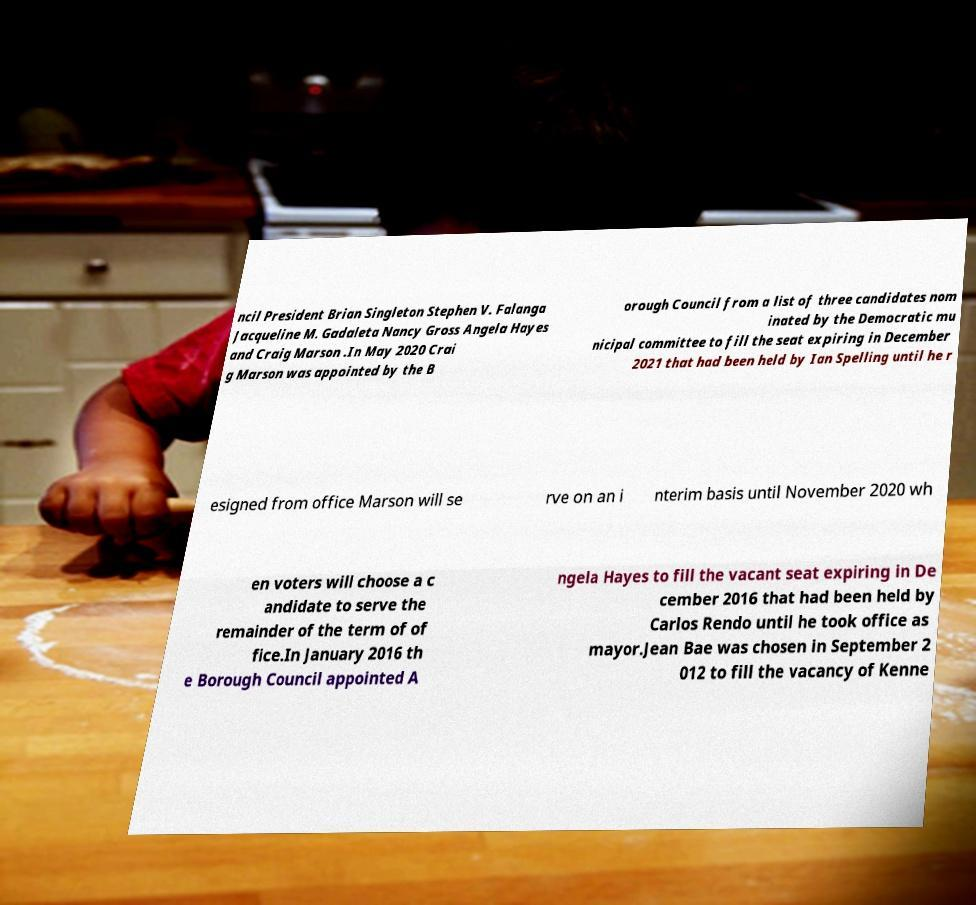Please identify and transcribe the text found in this image. ncil President Brian Singleton Stephen V. Falanga Jacqueline M. Gadaleta Nancy Gross Angela Hayes and Craig Marson .In May 2020 Crai g Marson was appointed by the B orough Council from a list of three candidates nom inated by the Democratic mu nicipal committee to fill the seat expiring in December 2021 that had been held by Ian Spelling until he r esigned from office Marson will se rve on an i nterim basis until November 2020 wh en voters will choose a c andidate to serve the remainder of the term of of fice.In January 2016 th e Borough Council appointed A ngela Hayes to fill the vacant seat expiring in De cember 2016 that had been held by Carlos Rendo until he took office as mayor.Jean Bae was chosen in September 2 012 to fill the vacancy of Kenne 